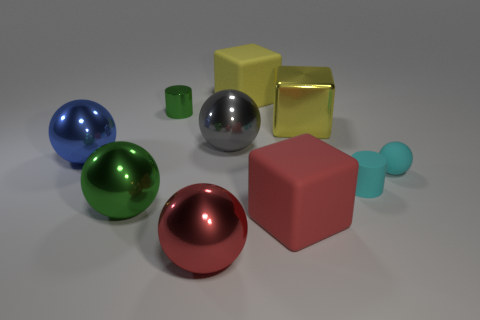Subtract all cyan balls. How many yellow blocks are left? 2 Subtract all tiny balls. How many balls are left? 4 Subtract all red balls. How many balls are left? 4 Subtract all red spheres. Subtract all cyan cubes. How many spheres are left? 4 Subtract all cylinders. How many objects are left? 8 Subtract all cyan balls. Subtract all small blue shiny objects. How many objects are left? 9 Add 9 metallic cylinders. How many metallic cylinders are left? 10 Add 1 small red cubes. How many small red cubes exist? 1 Subtract 0 blue cubes. How many objects are left? 10 